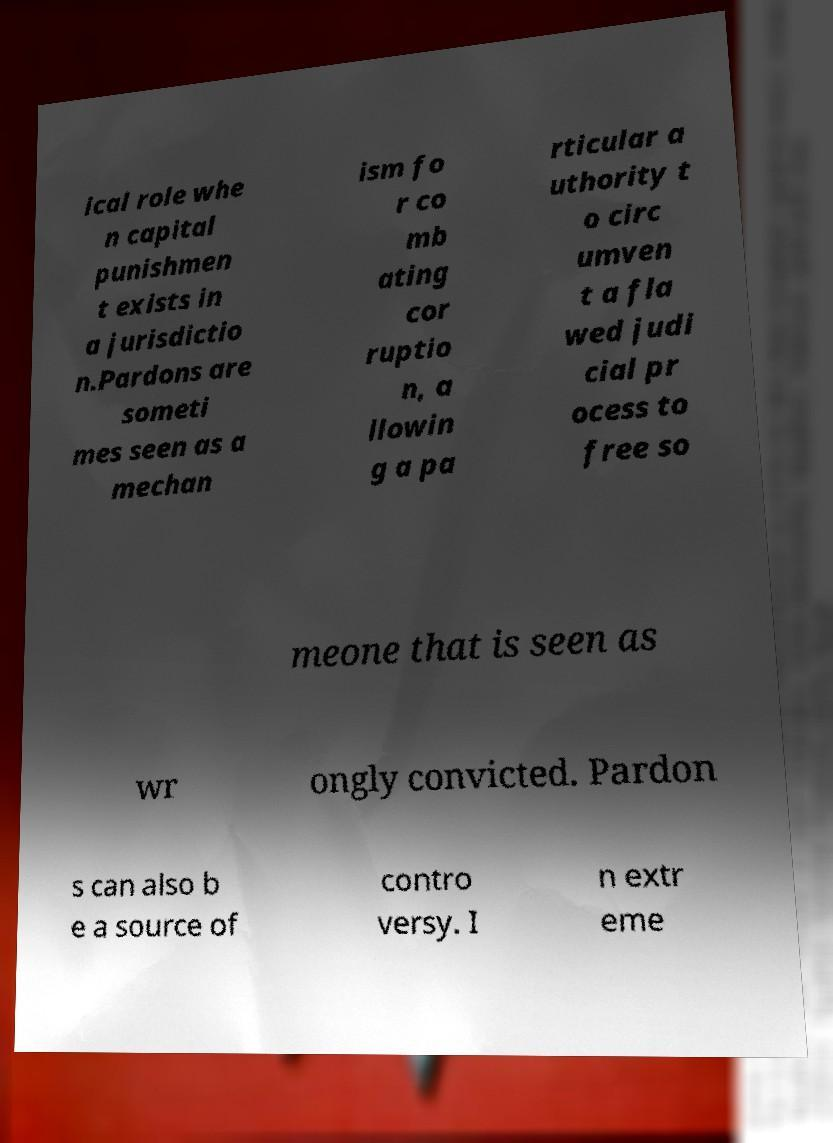Could you extract and type out the text from this image? ical role whe n capital punishmen t exists in a jurisdictio n.Pardons are someti mes seen as a mechan ism fo r co mb ating cor ruptio n, a llowin g a pa rticular a uthority t o circ umven t a fla wed judi cial pr ocess to free so meone that is seen as wr ongly convicted. Pardon s can also b e a source of contro versy. I n extr eme 